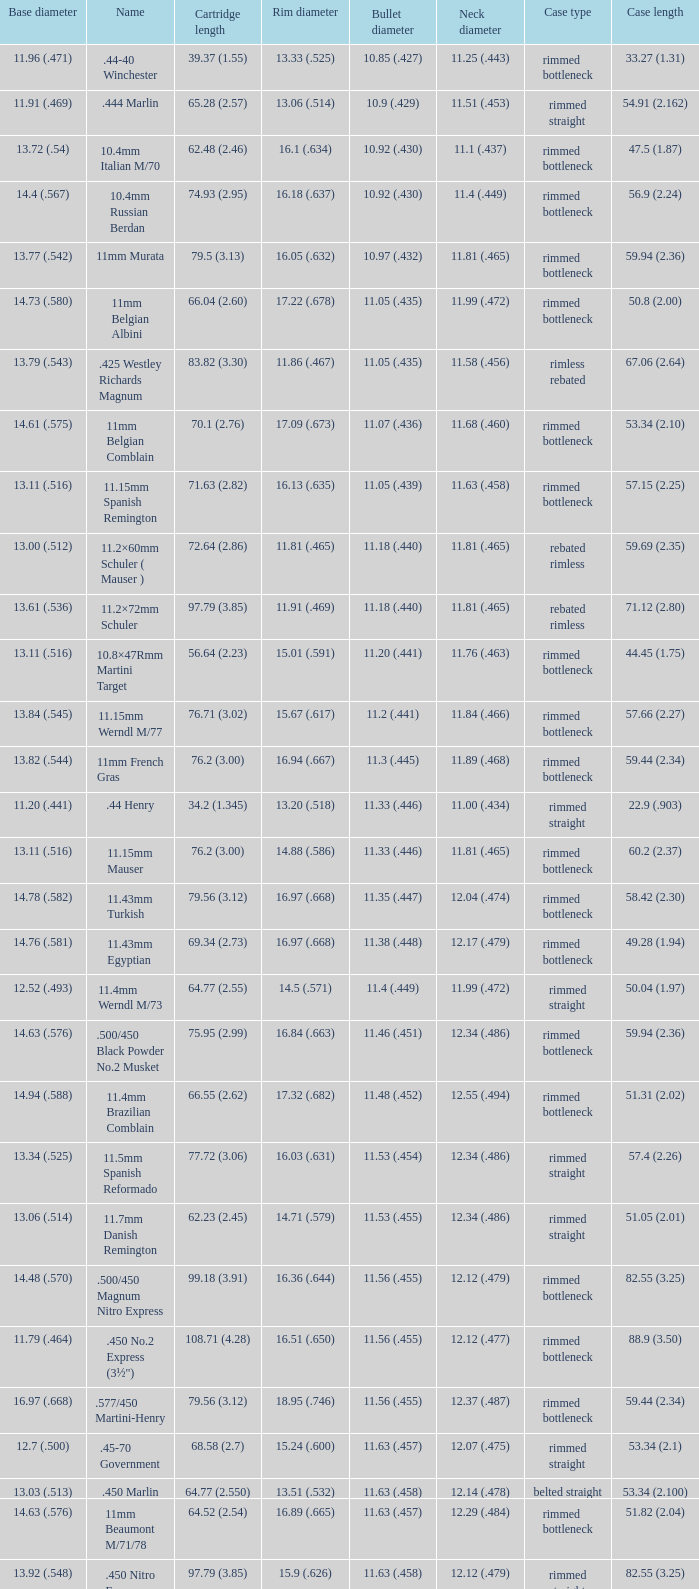Which Case length has a Rim diameter of 13.20 (.518)? 22.9 (.903). 